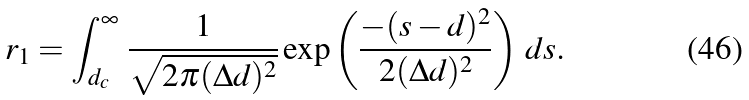<formula> <loc_0><loc_0><loc_500><loc_500>r _ { 1 } & = \int _ { d _ { c } } ^ { \infty } \, \frac { 1 } { \sqrt { 2 \pi ( \Delta d ) ^ { 2 } } } \exp \left ( \frac { - ( s - d ) ^ { 2 } } { 2 ( \Delta d ) ^ { 2 } } \right ) \, d s .</formula> 